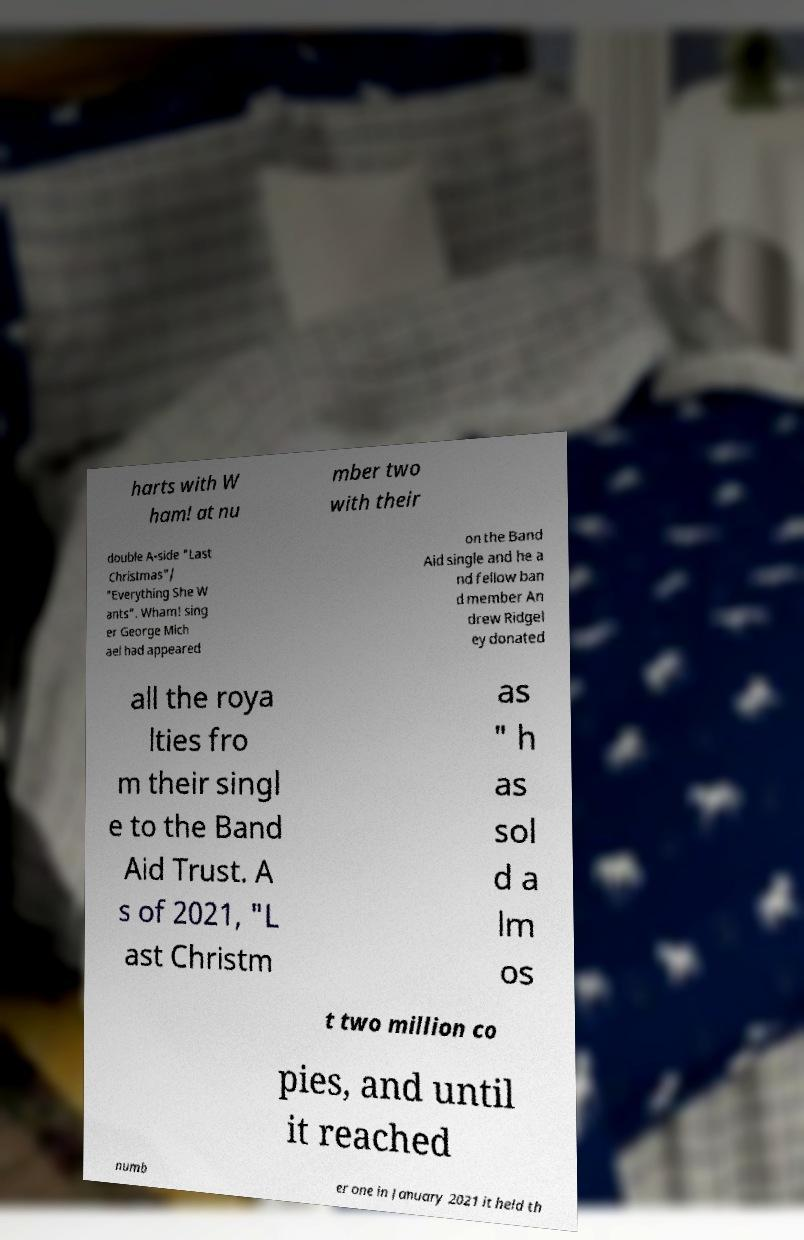Please identify and transcribe the text found in this image. harts with W ham! at nu mber two with their double A-side "Last Christmas"/ "Everything She W ants". Wham! sing er George Mich ael had appeared on the Band Aid single and he a nd fellow ban d member An drew Ridgel ey donated all the roya lties fro m their singl e to the Band Aid Trust. A s of 2021, "L ast Christm as " h as sol d a lm os t two million co pies, and until it reached numb er one in January 2021 it held th 